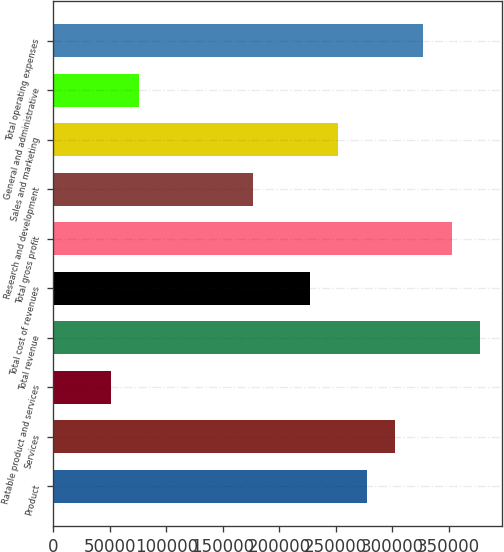Convert chart to OTSL. <chart><loc_0><loc_0><loc_500><loc_500><bar_chart><fcel>Product<fcel>Services<fcel>Ratable product and services<fcel>Total revenue<fcel>Total cost of revenues<fcel>Total gross profit<fcel>Research and development<fcel>Sales and marketing<fcel>General and administrative<fcel>Total operating expenses<nl><fcel>277307<fcel>302498<fcel>50581.4<fcel>378074<fcel>226923<fcel>352882<fcel>176540<fcel>252115<fcel>75773.1<fcel>327690<nl></chart> 